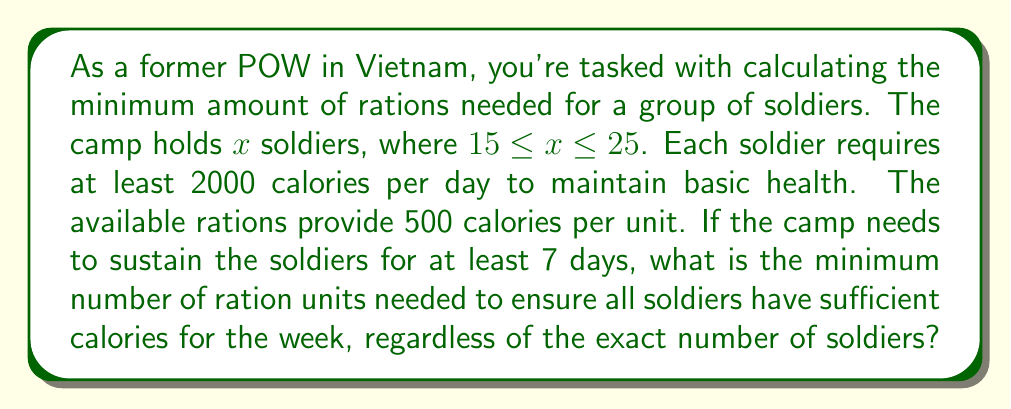Show me your answer to this math problem. Let's approach this step-by-step:

1) First, we need to consider the worst-case scenario, which is the maximum number of soldiers: $x = 25$

2) Calculate the total calories needed per soldier for 7 days:
   $$\text{Calories per soldier} = 2000 \text{ calories/day} \times 7 \text{ days} = 14000 \text{ calories}$$

3) Calculate the total calories needed for 25 soldiers:
   $$\text{Total calories} = 25 \text{ soldiers} \times 14000 \text{ calories} = 350000 \text{ calories}$$

4) Each ration unit provides 500 calories, so we need to divide the total calories by 500 to get the number of ration units:
   $$\text{Number of ration units} = \frac{350000 \text{ calories}}{500 \text{ calories/unit}}$$

5) Simplify:
   $$\text{Number of ration units} = 700$$

6) Since we can't have partial ration units, we need to round up to the nearest whole number. In this case, 700 is already a whole number.

Therefore, the minimum number of ration units needed is 700.
Answer: 700 ration units 